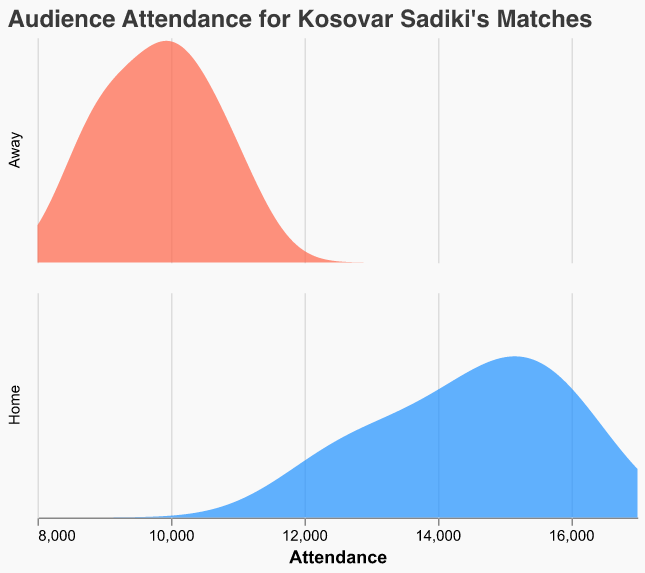Which location has the highest density peak in terms of attendance? The density plot shows two peaks, one representing home games and the other representing away games. The higher peak indicates the higher density of attendance values occurring at those values.
Answer: Home What is the range of attendance values considered in the plot? The density plot uses the attendance values within a certain extent for accurate visualization. The plot specifies an attendance range from 8000 to 17000.
Answer: 8000 to 17000 Which location shows a higher variance in attendance? By looking at the spread of the density curves, the larger spread indicates higher variance. The home games have a more spread-out density curve compared to away games.
Answer: Home What is the approximate peak attendance value for home games as shown in the plot? The peak of the density curve for home games is at a certain attendance value, which is where the curve reaches its maximum height. This seems to be around 15000.
Answer: 15000 How do the peak attendance values compare between home and away games? By comparing the peaks of the density curves for both home and away games, we can see which has a higher and which has a lower peak attendance. The home games' peak is around 15000, while the away games' peak is around 10000.
Answer: Home: 15000, Away: 10000 Are there any attendance values for away games that coincide with high-density regions for home games? By looking at the overlap and x-axis, if there are common high-density regions around specific attendance values for both home and away games, it indicates coincidence. There is no significant overlap in high-density regions between home and away games.
Answer: No Which location has a more consistent attendance according to the density plot, and why? Consistency is suggested by a tighter and higher peak in the density plot. Away games show a sharper peak, indicating more consistent attendance around a specific value.
Answer: Away What is the color used to represent home games in the plot? The legend or color encoding section of the plot shows the specific color used to differentiate home games. Home games are represented by blue.
Answer: Blue How does the density curve for away games compare to home games overall? By analyzing the overall shape, spread, and peaks of the density curves for both locations, we can compare their distributions. The density curve for away games is narrower and peaks around 10000, while the home games' curve is wider with higher peaks and spreads over a larger range of values.
Answer: Narrower and lower peak around 10000 for away games, wider and higher peaks up to 16000 for home games What percentage of home games had an attendance below 15000 based on the density plot? To find the percentage, estimate the proportion of the area under the home games' density curve that is to the left of the attendance value 15000. The area to the left of 15000 seems to cover less than half of the total area under the home curve.
Answer: Less than 50% 